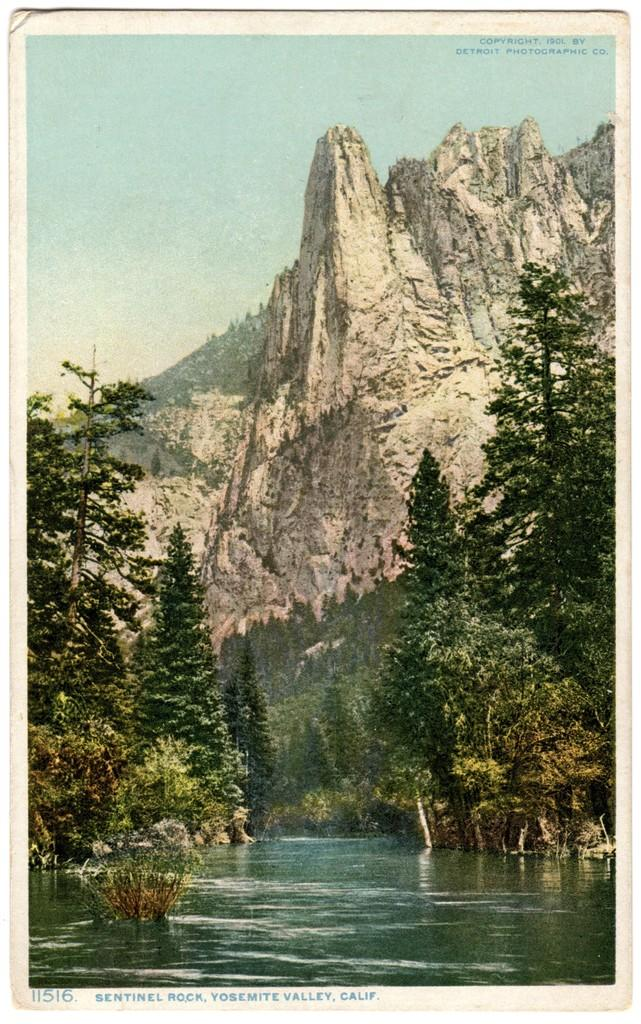What type of natural environment is depicted in the image? The image features trees, water, mountains, and rocks, which are all elements of a natural environment. Can you describe the water in the image? The image contains water, but it is not specified whether it is a river, lake, or other body of water. What is visible in the background of the image? The sky is visible in the background of the image. What type of drug can be seen in the image? There is no drug present in the image; it features a natural environment with trees, water, mountains, and rocks. 